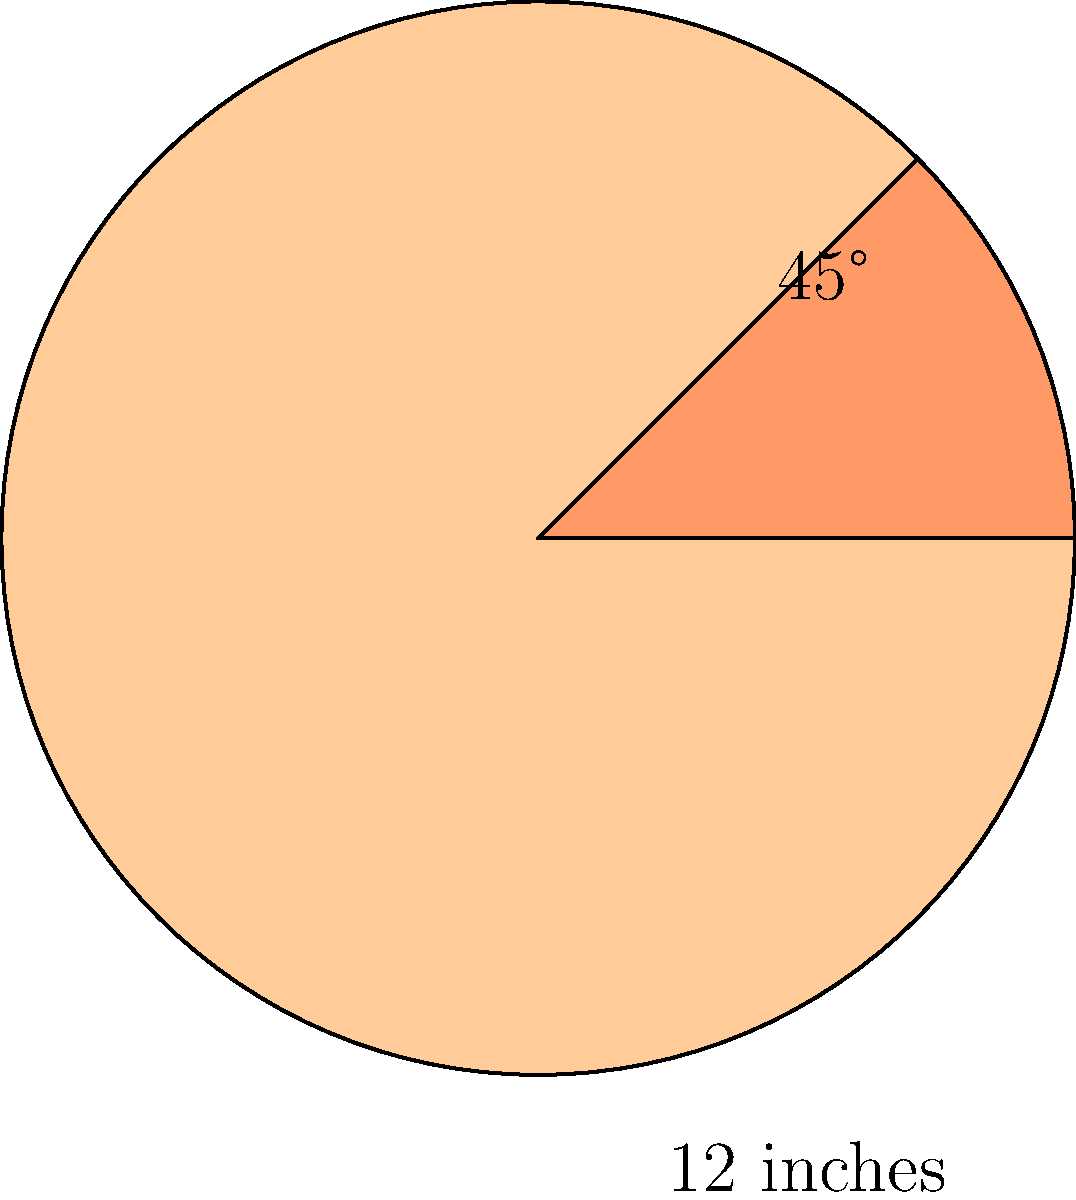At your part-time job at a pizzeria, you're tasked with cutting a large circular pizza into equal slices. The pizza pan has a diameter of 12 inches, and each slice should have a central angle of 45°. How many slices can you cut from this pizza, and what is the area of each slice in square inches? Round your answer to the nearest hundredth. Let's approach this step-by-step:

1. Calculate the number of slices:
   - A full circle is 360°
   - Each slice is 45°
   - Number of slices = $360° ÷ 45° = 8$ slices

2. Calculate the area of the entire pizza:
   - Area of a circle = $\pi r^2$
   - Radius = Diameter ÷ 2 = 12 ÷ 2 = 6 inches
   - Area = $\pi (6 \text{ in})^2 = 36\pi \text{ in}^2 \approx 113.10 \text{ in}^2$

3. Calculate the area of each slice:
   - Area of each slice = Total area ÷ Number of slices
   - Area of each slice = $113.10 \text{ in}^2 ÷ 8 = 14.14 \text{ in}^2$

Therefore, you can cut 8 slices from the pizza, and each slice will have an area of approximately 14.14 square inches.
Answer: 8 slices; 14.14 square inches per slice 